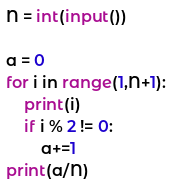Convert code to text. <code><loc_0><loc_0><loc_500><loc_500><_Python_>N = int(input())

a = 0
for i in range(1,N+1):
    print(i)
    if i % 2 != 0:
        a+=1
print(a/N)
</code> 